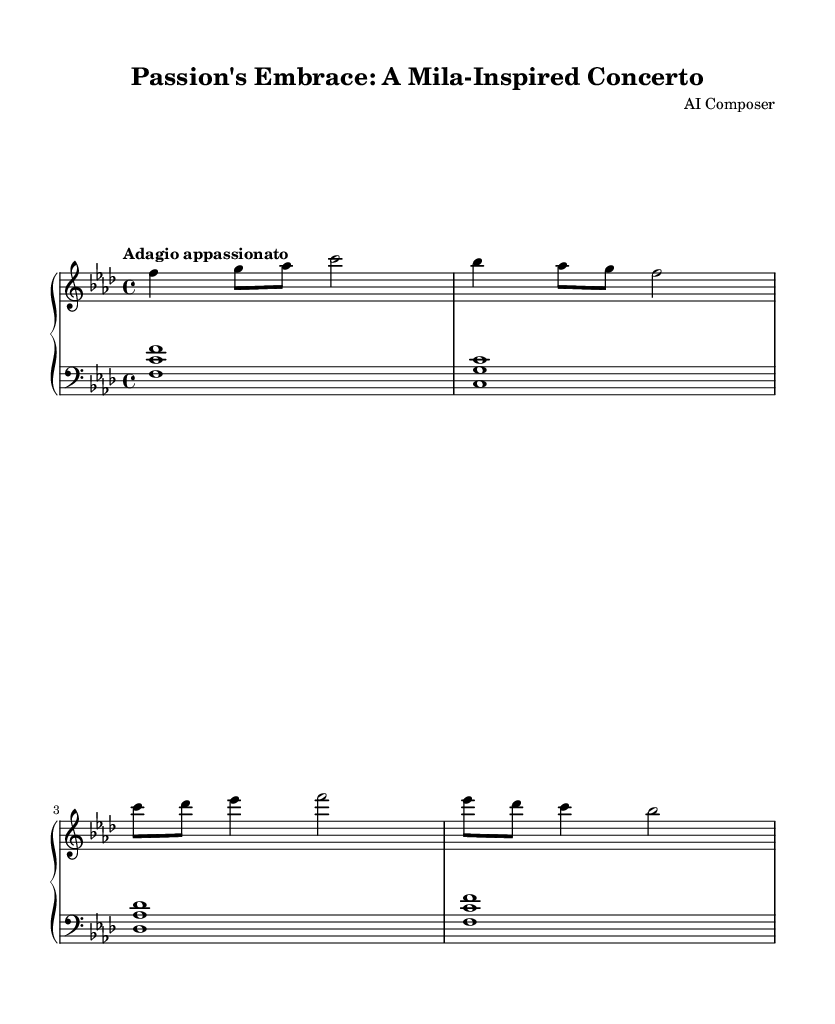What is the key signature of this music? The key signature has four flats, which corresponds to the key of F minor.
Answer: F minor What is the time signature of this music? The time signature is indicated as 4/4, meaning there are four beats per measure.
Answer: 4/4 What is the tempo marking for this piece? The tempo marking is "Adagio appassionato," suggesting a slow and passionate style of play.
Answer: Adagio appassionato How many measures are in the provided score? There are four measures shown in the score, as indicated by the grouping of the notation.
Answer: Four What type of chord does the left hand play in the first measure? The left hand plays a triad chord (F-C-F), which includes the root note and its fifth.
Answer: Triad What is the highest note played in the right-hand part? The highest note in the right hand is the C note, which appears in the second half of the phrase.
Answer: C What musical form characterizes this piece? The piece likely follows a ternary form, common in romantic concertos, as it presents contrasting themes.
Answer: Ternary 